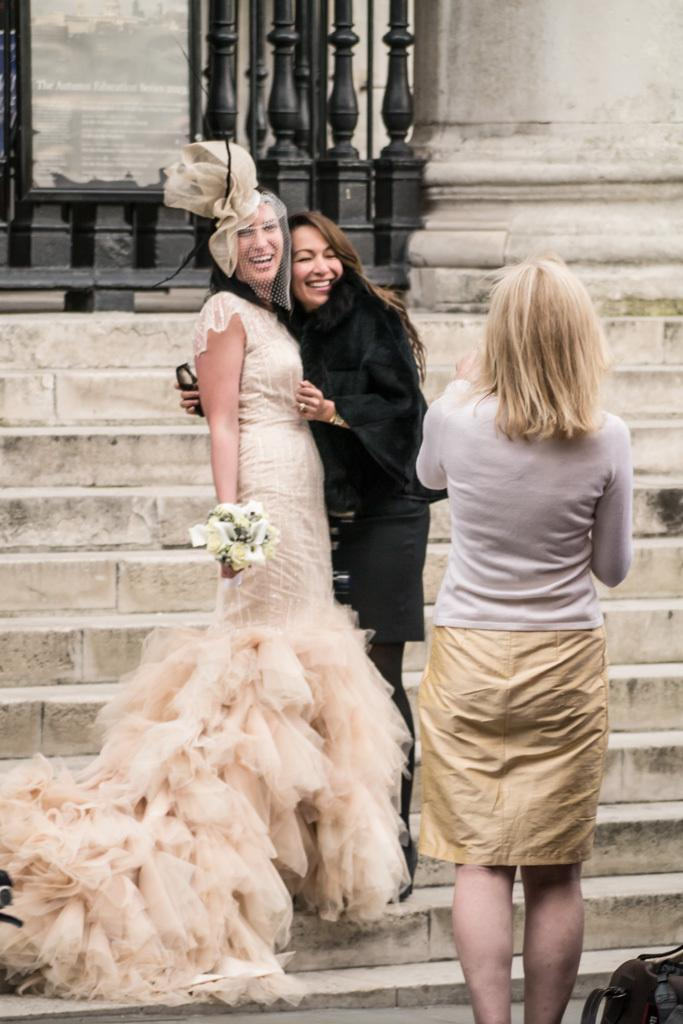What is the primary subject of the image? There is a person standing in the image. Can you describe the background of the image? There are two persons standing on a staircase and a board in the background of the image. What type of iron is being used by the person in the image? There is no iron present in the image; it features a person standing and a background with two persons on a staircase and a board. 